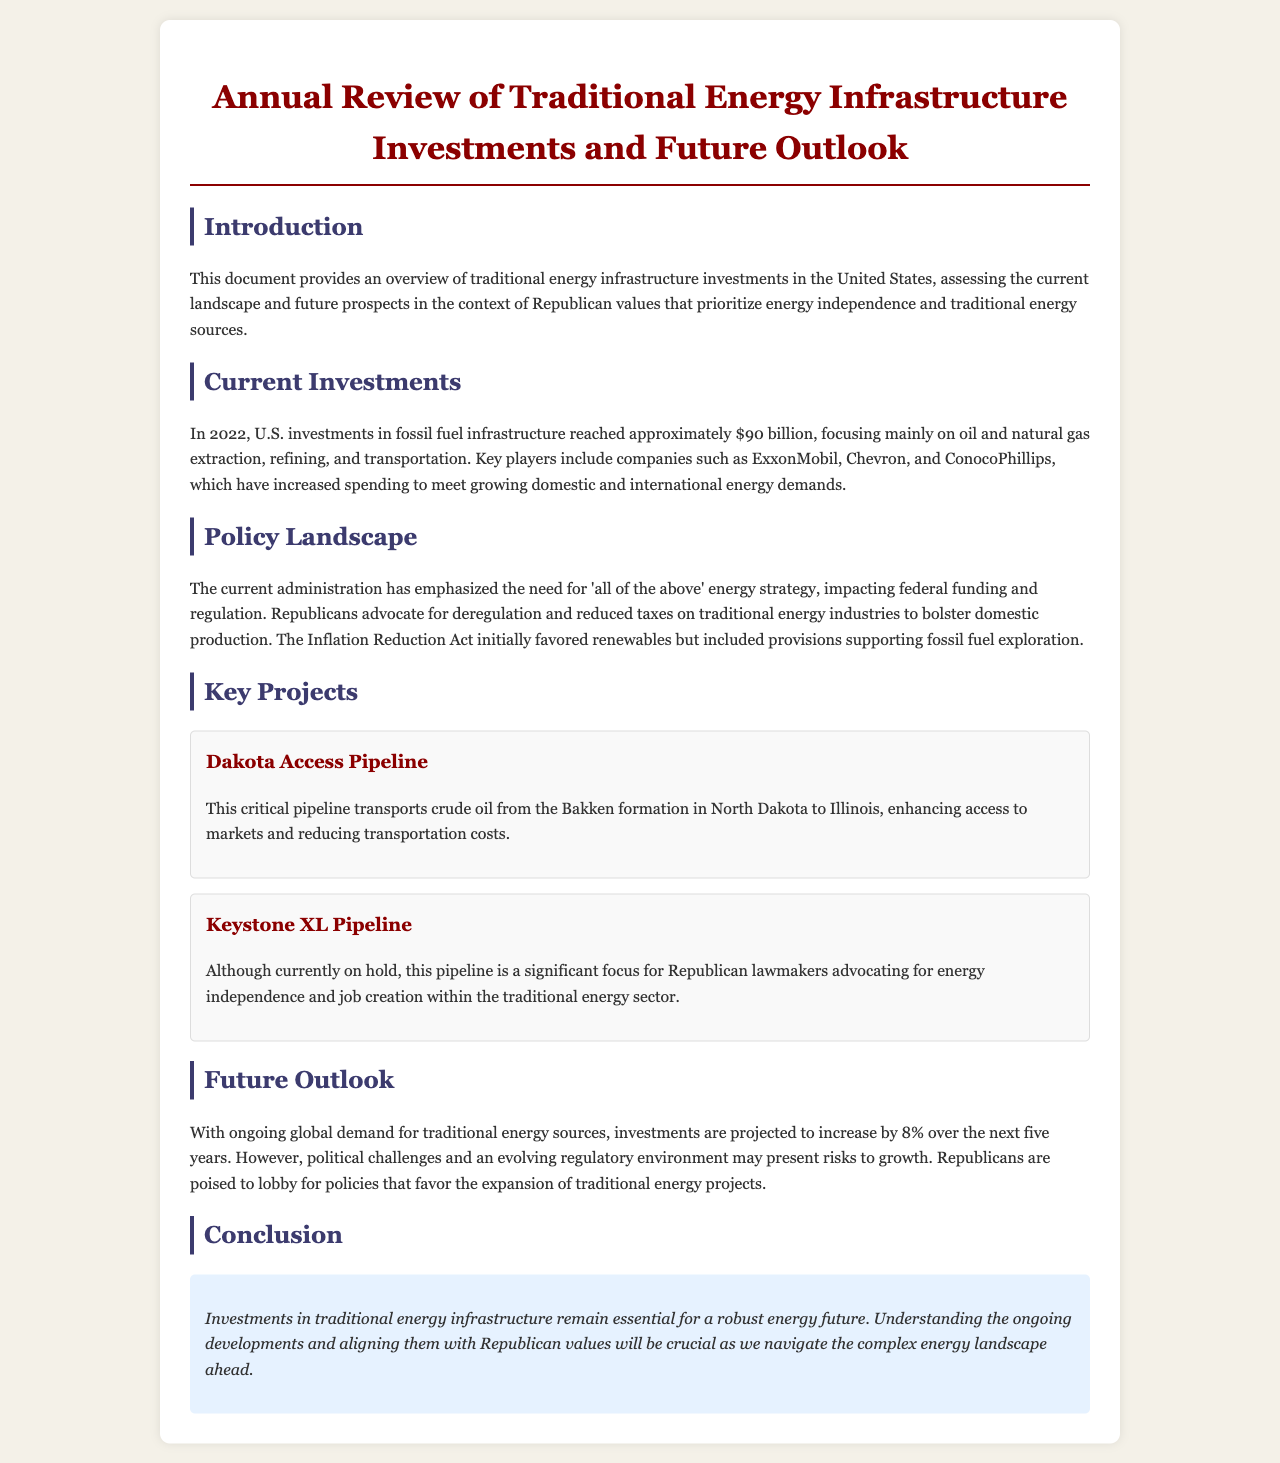What was the investment amount in fossil fuel infrastructure in 2022? The document states that U.S. investments in fossil fuel infrastructure reached approximately $90 billion in 2022.
Answer: $90 billion Which companies are mentioned as key players in fossil fuel investments? The document lists ExxonMobil, Chevron, and ConocoPhillips as key players in the fossil fuel investment landscape.
Answer: ExxonMobil, Chevron, ConocoPhillips What is the projected increase in investments over the next five years? The document forecasts that investments are projected to increase by 8% over the next five years.
Answer: 8% What policy do Republicans advocate for concerning traditional energy industries? The document indicates that Republicans advocate for deregulation and reduced taxes on traditional energy industries.
Answer: Deregulation and reduced taxes What is the status of the Keystone XL Pipeline? The document notes that the Keystone XL Pipeline is currently on hold.
Answer: On hold What critical project transports crude oil from North Dakota to Illinois? The document describes the Dakota Access Pipeline as transporting crude oil from the Bakken formation in North Dakota to Illinois.
Answer: Dakota Access Pipeline Which act initially favored renewables but included fossil fuel support? The document refers to the Inflation Reduction Act, which initially favored renewables but had provisions supporting fossil fuel exploration.
Answer: Inflation Reduction Act What is emphasized in the introduction regarding energy independence? The introduction emphasizes the need for energy independence within the context of traditional energy sources.
Answer: Energy independence 